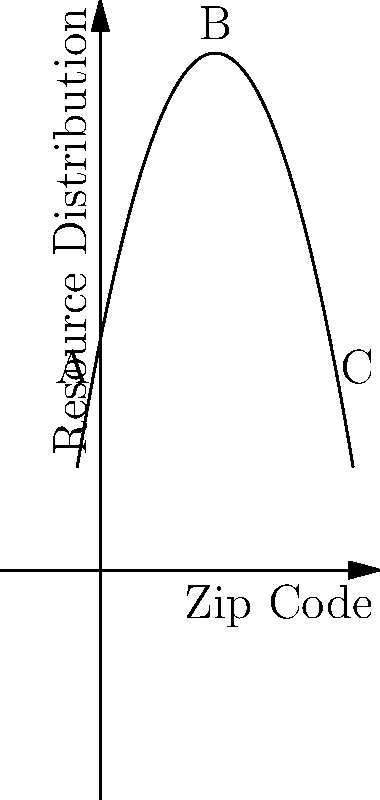A parabola is used to model the distribution of community resources across different zip codes in a city. The equation of the parabola is $f(x) = -0.5x^2 + 5x + 10$, where $x$ represents the zip code (scaled from 0 to 10) and $f(x)$ represents the resource allocation. Point B represents the zip code with the highest resource allocation. What is the approximate percentage decrease in resource allocation for the zip codes represented by points A and C compared to point B? To solve this problem, we'll follow these steps:

1) First, we need to find the coordinates of points A, B, and C.

   A: x = 0, f(0) = 10
   C: x = 10, f(10) = -0.5(10)^2 + 5(10) + 10 = -50 + 50 + 10 = 10
   
   For B, we need to find the vertex of the parabola:
   x = -b/(2a) = -5/(2(-0.5)) = 5
   f(5) = -0.5(5)^2 + 5(5) + 10 = -12.5 + 25 + 10 = 22.5

2) Now we have:
   A(0, 10)
   B(5, 22.5)
   C(10, 10)

3) To calculate the percentage decrease from B to A or C:
   Percentage decrease = (Decrease / Original Value) * 100
                       = ((22.5 - 10) / 22.5) * 100
                       = (12.5 / 22.5) * 100
                       ≈ 55.56%

Therefore, the resource allocation at points A and C is approximately 55.56% less than at point B.
Answer: 55.56% 